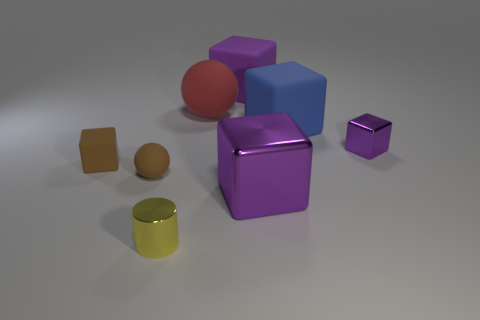There is a sphere that is in front of the small purple thing; what is its material?
Offer a very short reply. Rubber. What is the size of the cylinder?
Offer a terse response. Small. Does the matte block to the left of the yellow object have the same size as the rubber sphere that is on the left side of the big matte ball?
Your response must be concise. Yes. What is the size of the purple matte thing that is the same shape as the blue rubber object?
Offer a very short reply. Large. Do the blue object and the matte cube left of the yellow thing have the same size?
Make the answer very short. No. There is a purple block that is in front of the tiny purple shiny object; are there any large things behind it?
Provide a short and direct response. Yes. What shape is the brown object that is behind the small rubber sphere?
Your response must be concise. Cube. There is a tiny thing that is the same color as the big shiny object; what is it made of?
Provide a short and direct response. Metal. There is a tiny cube on the left side of the big cube that is in front of the tiny brown block; what is its color?
Your answer should be very brief. Brown. Is the yellow metal thing the same size as the red matte ball?
Provide a succinct answer. No. 